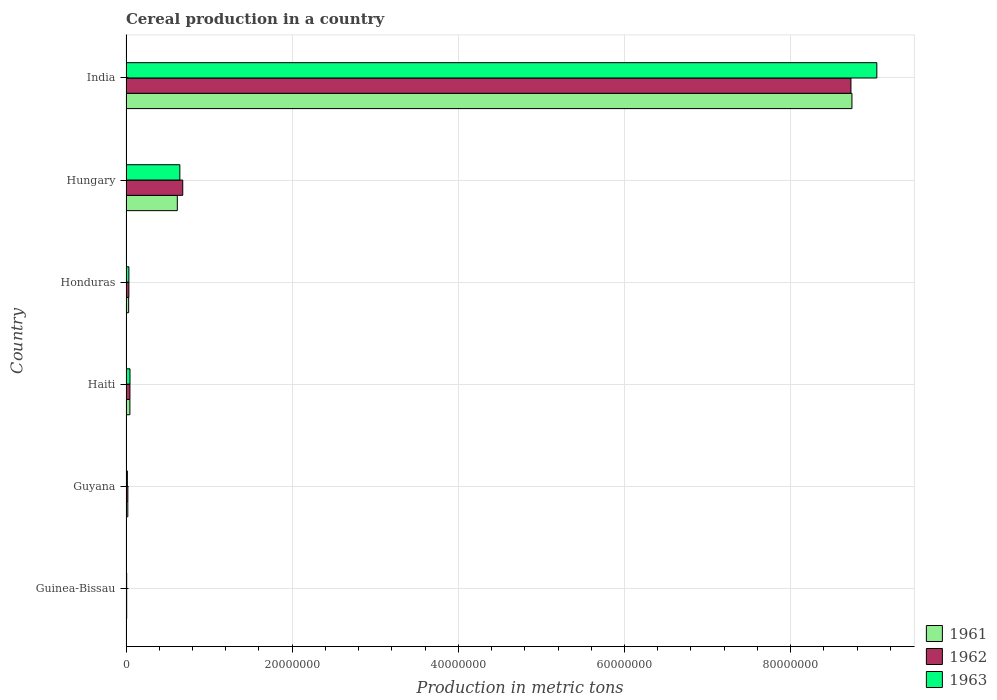How many different coloured bars are there?
Keep it short and to the point. 3. How many groups of bars are there?
Your answer should be compact. 6. How many bars are there on the 5th tick from the top?
Provide a short and direct response. 3. How many bars are there on the 4th tick from the bottom?
Your answer should be compact. 3. What is the label of the 4th group of bars from the top?
Offer a terse response. Haiti. What is the total cereal production in 1962 in India?
Your response must be concise. 8.73e+07. Across all countries, what is the maximum total cereal production in 1962?
Offer a very short reply. 8.73e+07. In which country was the total cereal production in 1963 minimum?
Offer a very short reply. Guinea-Bissau. What is the total total cereal production in 1962 in the graph?
Make the answer very short. 9.52e+07. What is the difference between the total cereal production in 1961 in Guyana and that in Haiti?
Your response must be concise. -2.50e+05. What is the difference between the total cereal production in 1963 in Honduras and the total cereal production in 1961 in Guinea-Bissau?
Your response must be concise. 2.68e+05. What is the average total cereal production in 1963 per country?
Provide a succinct answer. 1.63e+07. What is the difference between the total cereal production in 1963 and total cereal production in 1961 in India?
Your answer should be very brief. 3.00e+06. What is the ratio of the total cereal production in 1963 in Guinea-Bissau to that in Haiti?
Ensure brevity in your answer.  0.17. What is the difference between the highest and the second highest total cereal production in 1961?
Offer a terse response. 8.12e+07. What is the difference between the highest and the lowest total cereal production in 1962?
Make the answer very short. 8.72e+07. In how many countries, is the total cereal production in 1963 greater than the average total cereal production in 1963 taken over all countries?
Make the answer very short. 1. Is the sum of the total cereal production in 1961 in Haiti and Hungary greater than the maximum total cereal production in 1962 across all countries?
Make the answer very short. No. What does the 3rd bar from the top in Guinea-Bissau represents?
Your response must be concise. 1961. Are all the bars in the graph horizontal?
Your answer should be very brief. Yes. What is the difference between two consecutive major ticks on the X-axis?
Provide a short and direct response. 2.00e+07. Are the values on the major ticks of X-axis written in scientific E-notation?
Offer a terse response. No. How are the legend labels stacked?
Keep it short and to the point. Vertical. What is the title of the graph?
Offer a terse response. Cereal production in a country. Does "1978" appear as one of the legend labels in the graph?
Your answer should be very brief. No. What is the label or title of the X-axis?
Keep it short and to the point. Production in metric tons. What is the label or title of the Y-axis?
Provide a short and direct response. Country. What is the Production in metric tons of 1961 in Guinea-Bissau?
Offer a terse response. 7.90e+04. What is the Production in metric tons of 1962 in Guinea-Bissau?
Give a very brief answer. 7.95e+04. What is the Production in metric tons of 1961 in Guyana?
Offer a very short reply. 2.16e+05. What is the Production in metric tons in 1962 in Guyana?
Your answer should be very brief. 2.22e+05. What is the Production in metric tons of 1963 in Guyana?
Make the answer very short. 1.64e+05. What is the Production in metric tons in 1961 in Haiti?
Your answer should be compact. 4.66e+05. What is the Production in metric tons in 1962 in Haiti?
Your answer should be very brief. 4.72e+05. What is the Production in metric tons in 1963 in Haiti?
Provide a short and direct response. 4.78e+05. What is the Production in metric tons of 1961 in Honduras?
Offer a terse response. 3.18e+05. What is the Production in metric tons in 1962 in Honduras?
Offer a terse response. 3.44e+05. What is the Production in metric tons of 1963 in Honduras?
Give a very brief answer. 3.47e+05. What is the Production in metric tons in 1961 in Hungary?
Keep it short and to the point. 6.17e+06. What is the Production in metric tons in 1962 in Hungary?
Your response must be concise. 6.83e+06. What is the Production in metric tons of 1963 in Hungary?
Your answer should be very brief. 6.48e+06. What is the Production in metric tons in 1961 in India?
Offer a terse response. 8.74e+07. What is the Production in metric tons of 1962 in India?
Offer a terse response. 8.73e+07. What is the Production in metric tons in 1963 in India?
Make the answer very short. 9.04e+07. Across all countries, what is the maximum Production in metric tons in 1961?
Offer a very short reply. 8.74e+07. Across all countries, what is the maximum Production in metric tons of 1962?
Offer a very short reply. 8.73e+07. Across all countries, what is the maximum Production in metric tons in 1963?
Your response must be concise. 9.04e+07. Across all countries, what is the minimum Production in metric tons of 1961?
Provide a succinct answer. 7.90e+04. Across all countries, what is the minimum Production in metric tons in 1962?
Provide a succinct answer. 7.95e+04. What is the total Production in metric tons in 1961 in the graph?
Your answer should be very brief. 9.46e+07. What is the total Production in metric tons in 1962 in the graph?
Offer a terse response. 9.52e+07. What is the total Production in metric tons of 1963 in the graph?
Keep it short and to the point. 9.79e+07. What is the difference between the Production in metric tons in 1961 in Guinea-Bissau and that in Guyana?
Provide a short and direct response. -1.37e+05. What is the difference between the Production in metric tons in 1962 in Guinea-Bissau and that in Guyana?
Make the answer very short. -1.42e+05. What is the difference between the Production in metric tons of 1963 in Guinea-Bissau and that in Guyana?
Your response must be concise. -8.45e+04. What is the difference between the Production in metric tons of 1961 in Guinea-Bissau and that in Haiti?
Offer a very short reply. -3.87e+05. What is the difference between the Production in metric tons in 1962 in Guinea-Bissau and that in Haiti?
Make the answer very short. -3.93e+05. What is the difference between the Production in metric tons of 1963 in Guinea-Bissau and that in Haiti?
Make the answer very short. -3.98e+05. What is the difference between the Production in metric tons in 1961 in Guinea-Bissau and that in Honduras?
Keep it short and to the point. -2.39e+05. What is the difference between the Production in metric tons in 1962 in Guinea-Bissau and that in Honduras?
Keep it short and to the point. -2.64e+05. What is the difference between the Production in metric tons of 1963 in Guinea-Bissau and that in Honduras?
Ensure brevity in your answer.  -2.67e+05. What is the difference between the Production in metric tons of 1961 in Guinea-Bissau and that in Hungary?
Make the answer very short. -6.10e+06. What is the difference between the Production in metric tons in 1962 in Guinea-Bissau and that in Hungary?
Your answer should be very brief. -6.75e+06. What is the difference between the Production in metric tons in 1963 in Guinea-Bissau and that in Hungary?
Make the answer very short. -6.40e+06. What is the difference between the Production in metric tons of 1961 in Guinea-Bissau and that in India?
Keep it short and to the point. -8.73e+07. What is the difference between the Production in metric tons in 1962 in Guinea-Bissau and that in India?
Your answer should be very brief. -8.72e+07. What is the difference between the Production in metric tons of 1963 in Guinea-Bissau and that in India?
Your answer should be very brief. -9.03e+07. What is the difference between the Production in metric tons in 1961 in Guyana and that in Haiti?
Provide a succinct answer. -2.50e+05. What is the difference between the Production in metric tons in 1962 in Guyana and that in Haiti?
Provide a short and direct response. -2.51e+05. What is the difference between the Production in metric tons of 1963 in Guyana and that in Haiti?
Make the answer very short. -3.14e+05. What is the difference between the Production in metric tons of 1961 in Guyana and that in Honduras?
Ensure brevity in your answer.  -1.02e+05. What is the difference between the Production in metric tons of 1962 in Guyana and that in Honduras?
Your response must be concise. -1.22e+05. What is the difference between the Production in metric tons of 1963 in Guyana and that in Honduras?
Provide a short and direct response. -1.83e+05. What is the difference between the Production in metric tons of 1961 in Guyana and that in Hungary?
Provide a short and direct response. -5.96e+06. What is the difference between the Production in metric tons in 1962 in Guyana and that in Hungary?
Make the answer very short. -6.61e+06. What is the difference between the Production in metric tons of 1963 in Guyana and that in Hungary?
Give a very brief answer. -6.31e+06. What is the difference between the Production in metric tons in 1961 in Guyana and that in India?
Your answer should be compact. -8.72e+07. What is the difference between the Production in metric tons of 1962 in Guyana and that in India?
Provide a succinct answer. -8.70e+07. What is the difference between the Production in metric tons of 1963 in Guyana and that in India?
Give a very brief answer. -9.02e+07. What is the difference between the Production in metric tons in 1961 in Haiti and that in Honduras?
Your answer should be compact. 1.48e+05. What is the difference between the Production in metric tons of 1962 in Haiti and that in Honduras?
Provide a succinct answer. 1.29e+05. What is the difference between the Production in metric tons in 1963 in Haiti and that in Honduras?
Your response must be concise. 1.31e+05. What is the difference between the Production in metric tons of 1961 in Haiti and that in Hungary?
Give a very brief answer. -5.71e+06. What is the difference between the Production in metric tons in 1962 in Haiti and that in Hungary?
Keep it short and to the point. -6.36e+06. What is the difference between the Production in metric tons of 1963 in Haiti and that in Hungary?
Give a very brief answer. -6.00e+06. What is the difference between the Production in metric tons of 1961 in Haiti and that in India?
Keep it short and to the point. -8.69e+07. What is the difference between the Production in metric tons in 1962 in Haiti and that in India?
Offer a very short reply. -8.68e+07. What is the difference between the Production in metric tons of 1963 in Haiti and that in India?
Make the answer very short. -8.99e+07. What is the difference between the Production in metric tons of 1961 in Honduras and that in Hungary?
Ensure brevity in your answer.  -5.86e+06. What is the difference between the Production in metric tons of 1962 in Honduras and that in Hungary?
Your answer should be compact. -6.49e+06. What is the difference between the Production in metric tons in 1963 in Honduras and that in Hungary?
Give a very brief answer. -6.13e+06. What is the difference between the Production in metric tons in 1961 in Honduras and that in India?
Keep it short and to the point. -8.71e+07. What is the difference between the Production in metric tons of 1962 in Honduras and that in India?
Offer a terse response. -8.69e+07. What is the difference between the Production in metric tons in 1963 in Honduras and that in India?
Your answer should be compact. -9.00e+07. What is the difference between the Production in metric tons of 1961 in Hungary and that in India?
Offer a very short reply. -8.12e+07. What is the difference between the Production in metric tons in 1962 in Hungary and that in India?
Your answer should be very brief. -8.04e+07. What is the difference between the Production in metric tons of 1963 in Hungary and that in India?
Offer a terse response. -8.39e+07. What is the difference between the Production in metric tons in 1961 in Guinea-Bissau and the Production in metric tons in 1962 in Guyana?
Your answer should be very brief. -1.43e+05. What is the difference between the Production in metric tons of 1961 in Guinea-Bissau and the Production in metric tons of 1963 in Guyana?
Your answer should be very brief. -8.55e+04. What is the difference between the Production in metric tons of 1962 in Guinea-Bissau and the Production in metric tons of 1963 in Guyana?
Provide a short and direct response. -8.50e+04. What is the difference between the Production in metric tons in 1961 in Guinea-Bissau and the Production in metric tons in 1962 in Haiti?
Give a very brief answer. -3.94e+05. What is the difference between the Production in metric tons of 1961 in Guinea-Bissau and the Production in metric tons of 1963 in Haiti?
Keep it short and to the point. -3.99e+05. What is the difference between the Production in metric tons in 1962 in Guinea-Bissau and the Production in metric tons in 1963 in Haiti?
Keep it short and to the point. -3.98e+05. What is the difference between the Production in metric tons in 1961 in Guinea-Bissau and the Production in metric tons in 1962 in Honduras?
Make the answer very short. -2.65e+05. What is the difference between the Production in metric tons of 1961 in Guinea-Bissau and the Production in metric tons of 1963 in Honduras?
Provide a short and direct response. -2.68e+05. What is the difference between the Production in metric tons of 1962 in Guinea-Bissau and the Production in metric tons of 1963 in Honduras?
Ensure brevity in your answer.  -2.68e+05. What is the difference between the Production in metric tons in 1961 in Guinea-Bissau and the Production in metric tons in 1962 in Hungary?
Provide a short and direct response. -6.75e+06. What is the difference between the Production in metric tons of 1961 in Guinea-Bissau and the Production in metric tons of 1963 in Hungary?
Offer a terse response. -6.40e+06. What is the difference between the Production in metric tons in 1962 in Guinea-Bissau and the Production in metric tons in 1963 in Hungary?
Your answer should be very brief. -6.40e+06. What is the difference between the Production in metric tons in 1961 in Guinea-Bissau and the Production in metric tons in 1962 in India?
Provide a short and direct response. -8.72e+07. What is the difference between the Production in metric tons in 1961 in Guinea-Bissau and the Production in metric tons in 1963 in India?
Your answer should be very brief. -9.03e+07. What is the difference between the Production in metric tons in 1962 in Guinea-Bissau and the Production in metric tons in 1963 in India?
Offer a terse response. -9.03e+07. What is the difference between the Production in metric tons of 1961 in Guyana and the Production in metric tons of 1962 in Haiti?
Your answer should be very brief. -2.56e+05. What is the difference between the Production in metric tons of 1961 in Guyana and the Production in metric tons of 1963 in Haiti?
Your answer should be very brief. -2.62e+05. What is the difference between the Production in metric tons in 1962 in Guyana and the Production in metric tons in 1963 in Haiti?
Give a very brief answer. -2.56e+05. What is the difference between the Production in metric tons of 1961 in Guyana and the Production in metric tons of 1962 in Honduras?
Your answer should be compact. -1.27e+05. What is the difference between the Production in metric tons of 1961 in Guyana and the Production in metric tons of 1963 in Honduras?
Keep it short and to the point. -1.31e+05. What is the difference between the Production in metric tons in 1962 in Guyana and the Production in metric tons in 1963 in Honduras?
Your answer should be compact. -1.25e+05. What is the difference between the Production in metric tons of 1961 in Guyana and the Production in metric tons of 1962 in Hungary?
Offer a very short reply. -6.61e+06. What is the difference between the Production in metric tons in 1961 in Guyana and the Production in metric tons in 1963 in Hungary?
Ensure brevity in your answer.  -6.26e+06. What is the difference between the Production in metric tons of 1962 in Guyana and the Production in metric tons of 1963 in Hungary?
Provide a short and direct response. -6.26e+06. What is the difference between the Production in metric tons in 1961 in Guyana and the Production in metric tons in 1962 in India?
Your answer should be compact. -8.70e+07. What is the difference between the Production in metric tons in 1961 in Guyana and the Production in metric tons in 1963 in India?
Provide a short and direct response. -9.02e+07. What is the difference between the Production in metric tons in 1962 in Guyana and the Production in metric tons in 1963 in India?
Give a very brief answer. -9.02e+07. What is the difference between the Production in metric tons of 1961 in Haiti and the Production in metric tons of 1962 in Honduras?
Give a very brief answer. 1.22e+05. What is the difference between the Production in metric tons in 1961 in Haiti and the Production in metric tons in 1963 in Honduras?
Provide a succinct answer. 1.19e+05. What is the difference between the Production in metric tons of 1962 in Haiti and the Production in metric tons of 1963 in Honduras?
Give a very brief answer. 1.25e+05. What is the difference between the Production in metric tons in 1961 in Haiti and the Production in metric tons in 1962 in Hungary?
Your answer should be compact. -6.36e+06. What is the difference between the Production in metric tons of 1961 in Haiti and the Production in metric tons of 1963 in Hungary?
Your response must be concise. -6.01e+06. What is the difference between the Production in metric tons in 1962 in Haiti and the Production in metric tons in 1963 in Hungary?
Your answer should be very brief. -6.01e+06. What is the difference between the Production in metric tons of 1961 in Haiti and the Production in metric tons of 1962 in India?
Give a very brief answer. -8.68e+07. What is the difference between the Production in metric tons of 1961 in Haiti and the Production in metric tons of 1963 in India?
Offer a very short reply. -8.99e+07. What is the difference between the Production in metric tons of 1962 in Haiti and the Production in metric tons of 1963 in India?
Give a very brief answer. -8.99e+07. What is the difference between the Production in metric tons of 1961 in Honduras and the Production in metric tons of 1962 in Hungary?
Offer a very short reply. -6.51e+06. What is the difference between the Production in metric tons in 1961 in Honduras and the Production in metric tons in 1963 in Hungary?
Offer a terse response. -6.16e+06. What is the difference between the Production in metric tons in 1962 in Honduras and the Production in metric tons in 1963 in Hungary?
Offer a terse response. -6.14e+06. What is the difference between the Production in metric tons of 1961 in Honduras and the Production in metric tons of 1962 in India?
Provide a succinct answer. -8.69e+07. What is the difference between the Production in metric tons of 1961 in Honduras and the Production in metric tons of 1963 in India?
Offer a terse response. -9.01e+07. What is the difference between the Production in metric tons in 1962 in Honduras and the Production in metric tons in 1963 in India?
Give a very brief answer. -9.00e+07. What is the difference between the Production in metric tons in 1961 in Hungary and the Production in metric tons in 1962 in India?
Provide a succinct answer. -8.11e+07. What is the difference between the Production in metric tons in 1961 in Hungary and the Production in metric tons in 1963 in India?
Offer a terse response. -8.42e+07. What is the difference between the Production in metric tons in 1962 in Hungary and the Production in metric tons in 1963 in India?
Your answer should be compact. -8.35e+07. What is the average Production in metric tons of 1961 per country?
Offer a terse response. 1.58e+07. What is the average Production in metric tons of 1962 per country?
Ensure brevity in your answer.  1.59e+07. What is the average Production in metric tons in 1963 per country?
Keep it short and to the point. 1.63e+07. What is the difference between the Production in metric tons in 1961 and Production in metric tons in 1962 in Guinea-Bissau?
Your response must be concise. -500. What is the difference between the Production in metric tons in 1961 and Production in metric tons in 1963 in Guinea-Bissau?
Your answer should be very brief. -1000. What is the difference between the Production in metric tons in 1962 and Production in metric tons in 1963 in Guinea-Bissau?
Your response must be concise. -500. What is the difference between the Production in metric tons of 1961 and Production in metric tons of 1962 in Guyana?
Provide a short and direct response. -5445. What is the difference between the Production in metric tons in 1961 and Production in metric tons in 1963 in Guyana?
Provide a short and direct response. 5.19e+04. What is the difference between the Production in metric tons of 1962 and Production in metric tons of 1963 in Guyana?
Keep it short and to the point. 5.74e+04. What is the difference between the Production in metric tons in 1961 and Production in metric tons in 1962 in Haiti?
Give a very brief answer. -6500. What is the difference between the Production in metric tons of 1961 and Production in metric tons of 1963 in Haiti?
Give a very brief answer. -1.20e+04. What is the difference between the Production in metric tons of 1962 and Production in metric tons of 1963 in Haiti?
Ensure brevity in your answer.  -5500. What is the difference between the Production in metric tons of 1961 and Production in metric tons of 1962 in Honduras?
Offer a terse response. -2.57e+04. What is the difference between the Production in metric tons of 1961 and Production in metric tons of 1963 in Honduras?
Your answer should be compact. -2.92e+04. What is the difference between the Production in metric tons of 1962 and Production in metric tons of 1963 in Honduras?
Your answer should be compact. -3541. What is the difference between the Production in metric tons of 1961 and Production in metric tons of 1962 in Hungary?
Provide a succinct answer. -6.55e+05. What is the difference between the Production in metric tons in 1961 and Production in metric tons in 1963 in Hungary?
Your response must be concise. -3.04e+05. What is the difference between the Production in metric tons of 1962 and Production in metric tons of 1963 in Hungary?
Ensure brevity in your answer.  3.51e+05. What is the difference between the Production in metric tons of 1961 and Production in metric tons of 1962 in India?
Make the answer very short. 1.19e+05. What is the difference between the Production in metric tons of 1961 and Production in metric tons of 1963 in India?
Your response must be concise. -3.00e+06. What is the difference between the Production in metric tons in 1962 and Production in metric tons in 1963 in India?
Your answer should be very brief. -3.12e+06. What is the ratio of the Production in metric tons of 1961 in Guinea-Bissau to that in Guyana?
Offer a very short reply. 0.37. What is the ratio of the Production in metric tons in 1962 in Guinea-Bissau to that in Guyana?
Offer a very short reply. 0.36. What is the ratio of the Production in metric tons in 1963 in Guinea-Bissau to that in Guyana?
Keep it short and to the point. 0.49. What is the ratio of the Production in metric tons of 1961 in Guinea-Bissau to that in Haiti?
Your answer should be very brief. 0.17. What is the ratio of the Production in metric tons of 1962 in Guinea-Bissau to that in Haiti?
Ensure brevity in your answer.  0.17. What is the ratio of the Production in metric tons of 1963 in Guinea-Bissau to that in Haiti?
Give a very brief answer. 0.17. What is the ratio of the Production in metric tons of 1961 in Guinea-Bissau to that in Honduras?
Your answer should be compact. 0.25. What is the ratio of the Production in metric tons of 1962 in Guinea-Bissau to that in Honduras?
Offer a terse response. 0.23. What is the ratio of the Production in metric tons in 1963 in Guinea-Bissau to that in Honduras?
Provide a succinct answer. 0.23. What is the ratio of the Production in metric tons in 1961 in Guinea-Bissau to that in Hungary?
Give a very brief answer. 0.01. What is the ratio of the Production in metric tons in 1962 in Guinea-Bissau to that in Hungary?
Keep it short and to the point. 0.01. What is the ratio of the Production in metric tons of 1963 in Guinea-Bissau to that in Hungary?
Your answer should be compact. 0.01. What is the ratio of the Production in metric tons in 1961 in Guinea-Bissau to that in India?
Your answer should be compact. 0. What is the ratio of the Production in metric tons of 1962 in Guinea-Bissau to that in India?
Make the answer very short. 0. What is the ratio of the Production in metric tons in 1963 in Guinea-Bissau to that in India?
Your answer should be very brief. 0. What is the ratio of the Production in metric tons in 1961 in Guyana to that in Haiti?
Keep it short and to the point. 0.46. What is the ratio of the Production in metric tons of 1962 in Guyana to that in Haiti?
Offer a terse response. 0.47. What is the ratio of the Production in metric tons in 1963 in Guyana to that in Haiti?
Your answer should be very brief. 0.34. What is the ratio of the Production in metric tons in 1961 in Guyana to that in Honduras?
Your response must be concise. 0.68. What is the ratio of the Production in metric tons of 1962 in Guyana to that in Honduras?
Offer a very short reply. 0.65. What is the ratio of the Production in metric tons in 1963 in Guyana to that in Honduras?
Offer a terse response. 0.47. What is the ratio of the Production in metric tons of 1961 in Guyana to that in Hungary?
Offer a very short reply. 0.04. What is the ratio of the Production in metric tons of 1962 in Guyana to that in Hungary?
Offer a terse response. 0.03. What is the ratio of the Production in metric tons of 1963 in Guyana to that in Hungary?
Your response must be concise. 0.03. What is the ratio of the Production in metric tons in 1961 in Guyana to that in India?
Ensure brevity in your answer.  0. What is the ratio of the Production in metric tons in 1962 in Guyana to that in India?
Keep it short and to the point. 0. What is the ratio of the Production in metric tons in 1963 in Guyana to that in India?
Make the answer very short. 0. What is the ratio of the Production in metric tons of 1961 in Haiti to that in Honduras?
Make the answer very short. 1.47. What is the ratio of the Production in metric tons in 1962 in Haiti to that in Honduras?
Offer a terse response. 1.37. What is the ratio of the Production in metric tons in 1963 in Haiti to that in Honduras?
Provide a short and direct response. 1.38. What is the ratio of the Production in metric tons in 1961 in Haiti to that in Hungary?
Your response must be concise. 0.08. What is the ratio of the Production in metric tons of 1962 in Haiti to that in Hungary?
Your answer should be compact. 0.07. What is the ratio of the Production in metric tons of 1963 in Haiti to that in Hungary?
Keep it short and to the point. 0.07. What is the ratio of the Production in metric tons in 1961 in Haiti to that in India?
Ensure brevity in your answer.  0.01. What is the ratio of the Production in metric tons of 1962 in Haiti to that in India?
Make the answer very short. 0.01. What is the ratio of the Production in metric tons of 1963 in Haiti to that in India?
Ensure brevity in your answer.  0.01. What is the ratio of the Production in metric tons in 1961 in Honduras to that in Hungary?
Your answer should be very brief. 0.05. What is the ratio of the Production in metric tons of 1962 in Honduras to that in Hungary?
Your response must be concise. 0.05. What is the ratio of the Production in metric tons of 1963 in Honduras to that in Hungary?
Your response must be concise. 0.05. What is the ratio of the Production in metric tons of 1961 in Honduras to that in India?
Provide a succinct answer. 0. What is the ratio of the Production in metric tons in 1962 in Honduras to that in India?
Your answer should be very brief. 0. What is the ratio of the Production in metric tons in 1963 in Honduras to that in India?
Offer a terse response. 0. What is the ratio of the Production in metric tons in 1961 in Hungary to that in India?
Offer a terse response. 0.07. What is the ratio of the Production in metric tons of 1962 in Hungary to that in India?
Your response must be concise. 0.08. What is the ratio of the Production in metric tons in 1963 in Hungary to that in India?
Keep it short and to the point. 0.07. What is the difference between the highest and the second highest Production in metric tons in 1961?
Offer a very short reply. 8.12e+07. What is the difference between the highest and the second highest Production in metric tons in 1962?
Offer a very short reply. 8.04e+07. What is the difference between the highest and the second highest Production in metric tons of 1963?
Your response must be concise. 8.39e+07. What is the difference between the highest and the lowest Production in metric tons in 1961?
Your answer should be compact. 8.73e+07. What is the difference between the highest and the lowest Production in metric tons in 1962?
Give a very brief answer. 8.72e+07. What is the difference between the highest and the lowest Production in metric tons of 1963?
Ensure brevity in your answer.  9.03e+07. 